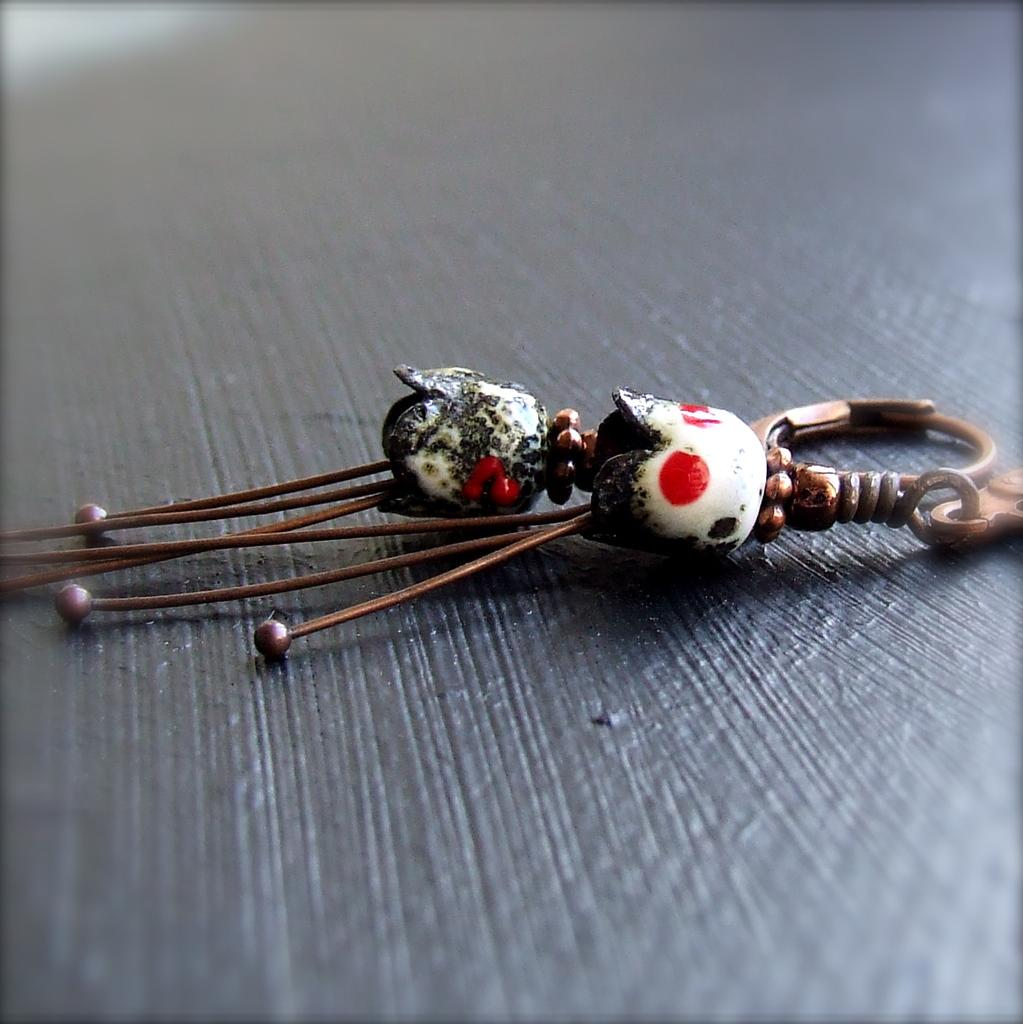What object in the image resembles a key-chain? There is an object in the image that resembles a key-chain. Where is the key-chain located in the image? The key-chain is on a wooden surface. What type of farmer is depicted in the image? There is no farmer present in the image; it only features a key-chain on a wooden surface. 